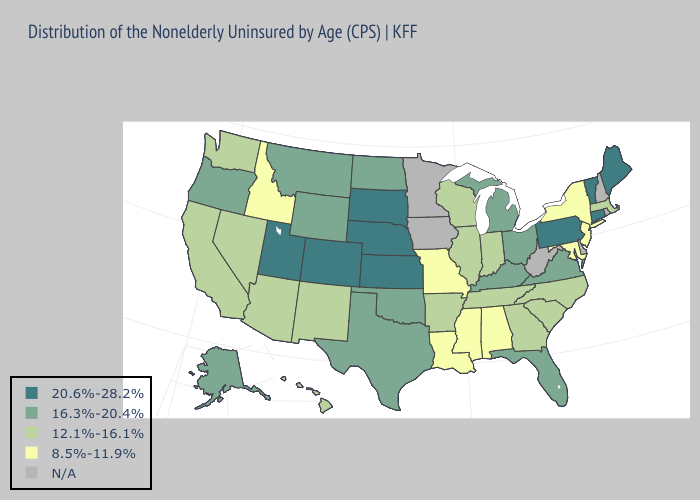What is the value of Virginia?
Answer briefly. 16.3%-20.4%. Among the states that border Georgia , does North Carolina have the highest value?
Answer briefly. No. Name the states that have a value in the range 12.1%-16.1%?
Be succinct. Arizona, Arkansas, California, Georgia, Hawaii, Illinois, Indiana, Massachusetts, Nevada, New Mexico, North Carolina, South Carolina, Tennessee, Washington, Wisconsin. How many symbols are there in the legend?
Answer briefly. 5. Which states have the lowest value in the USA?
Answer briefly. Alabama, Idaho, Louisiana, Maryland, Mississippi, Missouri, New Jersey, New York. What is the highest value in the USA?
Quick response, please. 20.6%-28.2%. Does the first symbol in the legend represent the smallest category?
Write a very short answer. No. Which states have the lowest value in the Northeast?
Keep it brief. New Jersey, New York. What is the lowest value in the USA?
Give a very brief answer. 8.5%-11.9%. What is the lowest value in states that border Rhode Island?
Short answer required. 12.1%-16.1%. Name the states that have a value in the range 8.5%-11.9%?
Keep it brief. Alabama, Idaho, Louisiana, Maryland, Mississippi, Missouri, New Jersey, New York. Which states have the highest value in the USA?
Give a very brief answer. Colorado, Connecticut, Kansas, Maine, Nebraska, Pennsylvania, South Dakota, Utah, Vermont. 